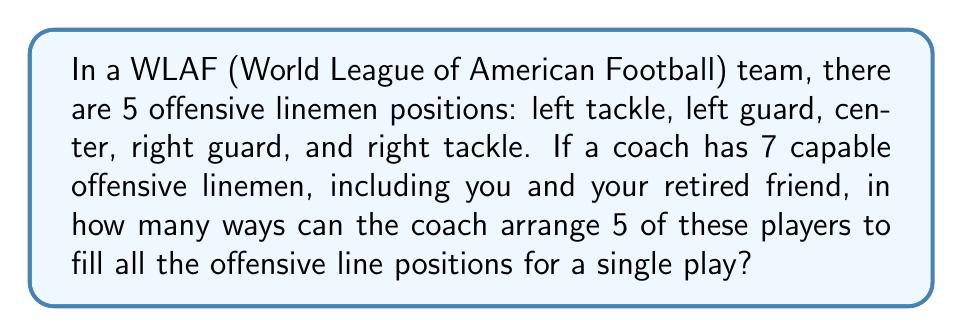Teach me how to tackle this problem. Let's approach this step-by-step:

1) First, we need to choose 5 players out of the 7 available. This is a combination problem.

2) The number of ways to choose 5 players from 7 is given by the combination formula:

   $$\binom{7}{5} = \frac{7!}{5!(7-5)!} = \frac{7!}{5!2!}$$

3) Calculating this:
   $$\frac{7 \cdot 6 \cdot 5!}{5! \cdot 2 \cdot 1} = \frac{42}{2} = 21$$

4) Now, for each of these 21 combinations, we need to arrange the 5 chosen players in the 5 positions. This is a permutation of 5 players.

5) The number of ways to arrange 5 players in 5 positions is simply 5!, which is:
   $$5! = 5 \cdot 4 \cdot 3 \cdot 2 \cdot 1 = 120$$

6) By the multiplication principle, the total number of ways to choose 5 players and arrange them is:

   $$21 \cdot 120 = 2520$$

Therefore, there are 2520 different ways the coach can arrange 5 of the 7 players in the offensive line positions.
Answer: 2520 